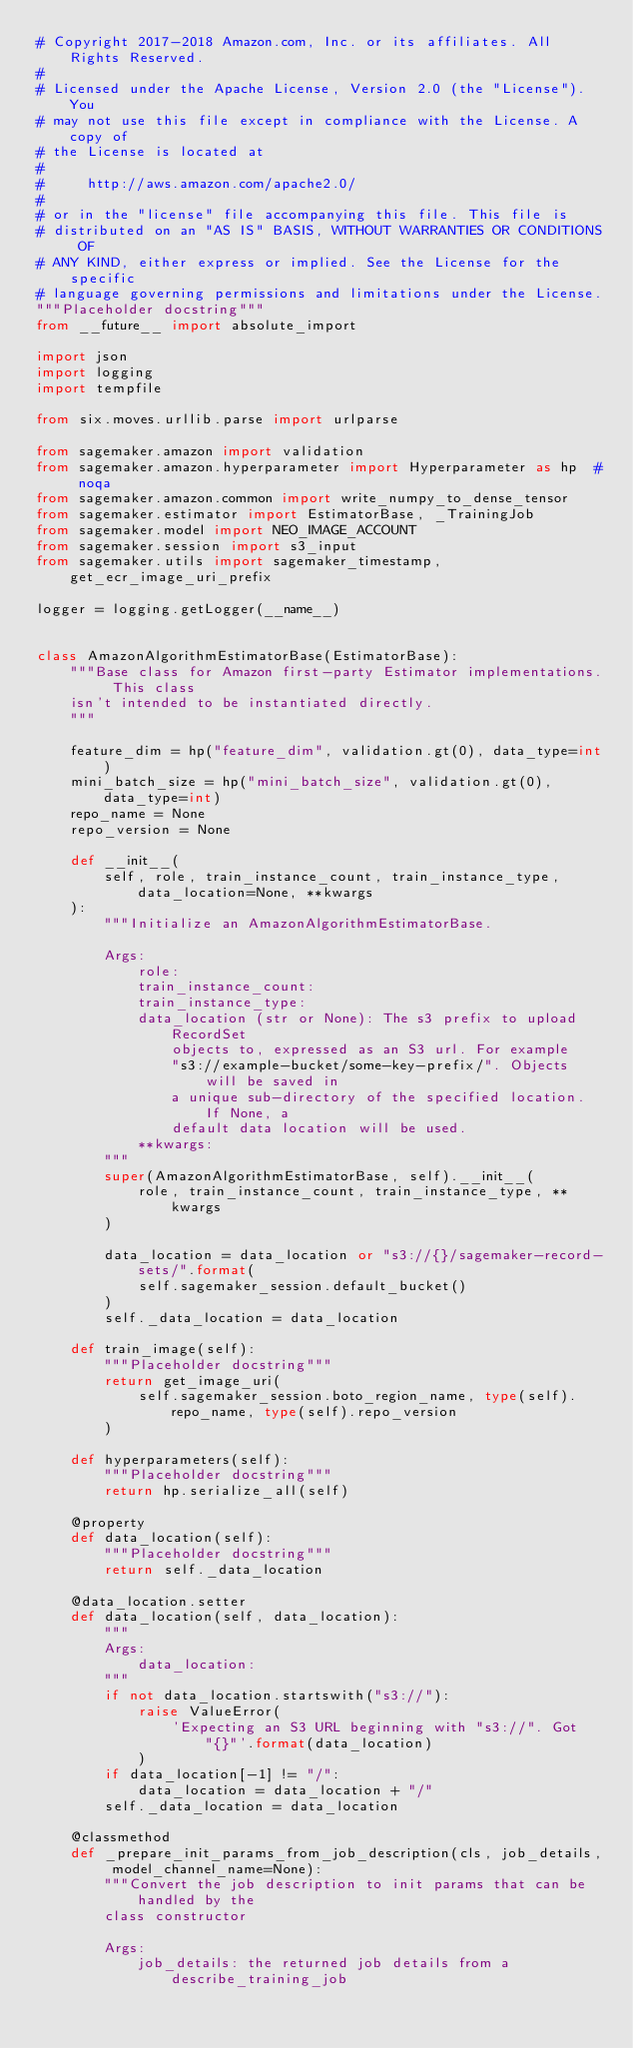<code> <loc_0><loc_0><loc_500><loc_500><_Python_># Copyright 2017-2018 Amazon.com, Inc. or its affiliates. All Rights Reserved.
#
# Licensed under the Apache License, Version 2.0 (the "License"). You
# may not use this file except in compliance with the License. A copy of
# the License is located at
#
#     http://aws.amazon.com/apache2.0/
#
# or in the "license" file accompanying this file. This file is
# distributed on an "AS IS" BASIS, WITHOUT WARRANTIES OR CONDITIONS OF
# ANY KIND, either express or implied. See the License for the specific
# language governing permissions and limitations under the License.
"""Placeholder docstring"""
from __future__ import absolute_import

import json
import logging
import tempfile

from six.moves.urllib.parse import urlparse

from sagemaker.amazon import validation
from sagemaker.amazon.hyperparameter import Hyperparameter as hp  # noqa
from sagemaker.amazon.common import write_numpy_to_dense_tensor
from sagemaker.estimator import EstimatorBase, _TrainingJob
from sagemaker.model import NEO_IMAGE_ACCOUNT
from sagemaker.session import s3_input
from sagemaker.utils import sagemaker_timestamp, get_ecr_image_uri_prefix

logger = logging.getLogger(__name__)


class AmazonAlgorithmEstimatorBase(EstimatorBase):
    """Base class for Amazon first-party Estimator implementations. This class
    isn't intended to be instantiated directly.
    """

    feature_dim = hp("feature_dim", validation.gt(0), data_type=int)
    mini_batch_size = hp("mini_batch_size", validation.gt(0), data_type=int)
    repo_name = None
    repo_version = None

    def __init__(
        self, role, train_instance_count, train_instance_type, data_location=None, **kwargs
    ):
        """Initialize an AmazonAlgorithmEstimatorBase.

        Args:
            role:
            train_instance_count:
            train_instance_type:
            data_location (str or None): The s3 prefix to upload RecordSet
                objects to, expressed as an S3 url. For example
                "s3://example-bucket/some-key-prefix/". Objects will be saved in
                a unique sub-directory of the specified location. If None, a
                default data location will be used.
            **kwargs:
        """
        super(AmazonAlgorithmEstimatorBase, self).__init__(
            role, train_instance_count, train_instance_type, **kwargs
        )

        data_location = data_location or "s3://{}/sagemaker-record-sets/".format(
            self.sagemaker_session.default_bucket()
        )
        self._data_location = data_location

    def train_image(self):
        """Placeholder docstring"""
        return get_image_uri(
            self.sagemaker_session.boto_region_name, type(self).repo_name, type(self).repo_version
        )

    def hyperparameters(self):
        """Placeholder docstring"""
        return hp.serialize_all(self)

    @property
    def data_location(self):
        """Placeholder docstring"""
        return self._data_location

    @data_location.setter
    def data_location(self, data_location):
        """
        Args:
            data_location:
        """
        if not data_location.startswith("s3://"):
            raise ValueError(
                'Expecting an S3 URL beginning with "s3://". Got "{}"'.format(data_location)
            )
        if data_location[-1] != "/":
            data_location = data_location + "/"
        self._data_location = data_location

    @classmethod
    def _prepare_init_params_from_job_description(cls, job_details, model_channel_name=None):
        """Convert the job description to init params that can be handled by the
        class constructor

        Args:
            job_details: the returned job details from a describe_training_job</code> 